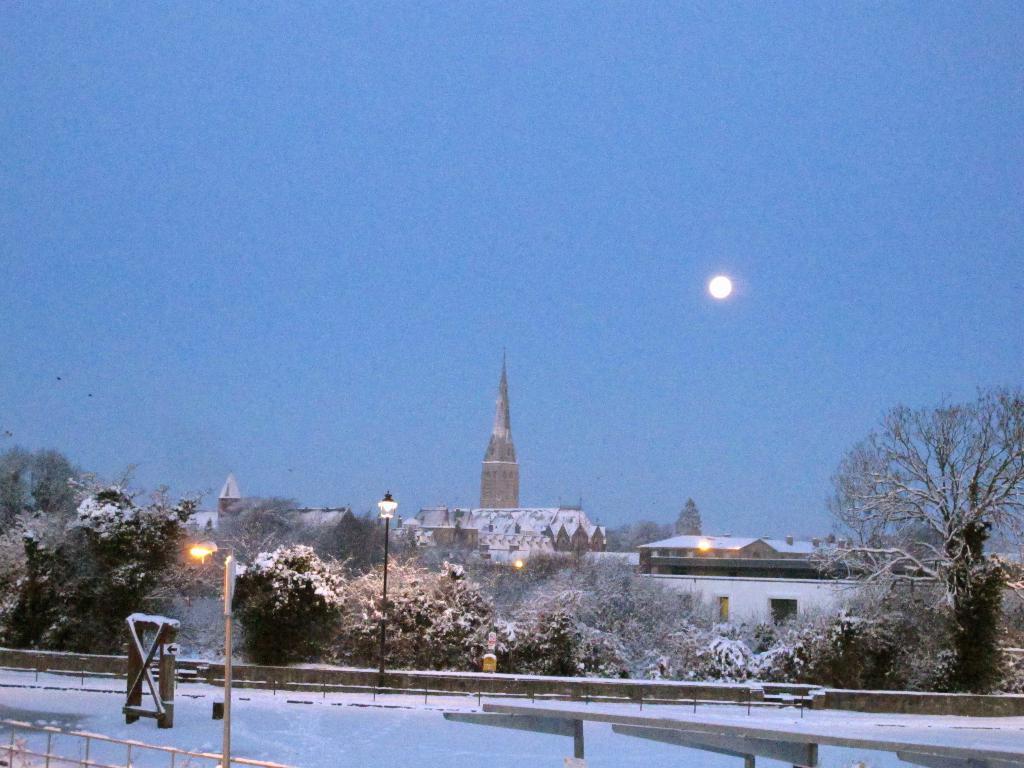Please provide a concise description of this image. In the foreground we can see the snow on the road. Here we can see the metal fence on both sides of the road. Here we can see the light pole on the side of a road. In the background, we can see the houses and trees. Here we can see the moon in the sky. 